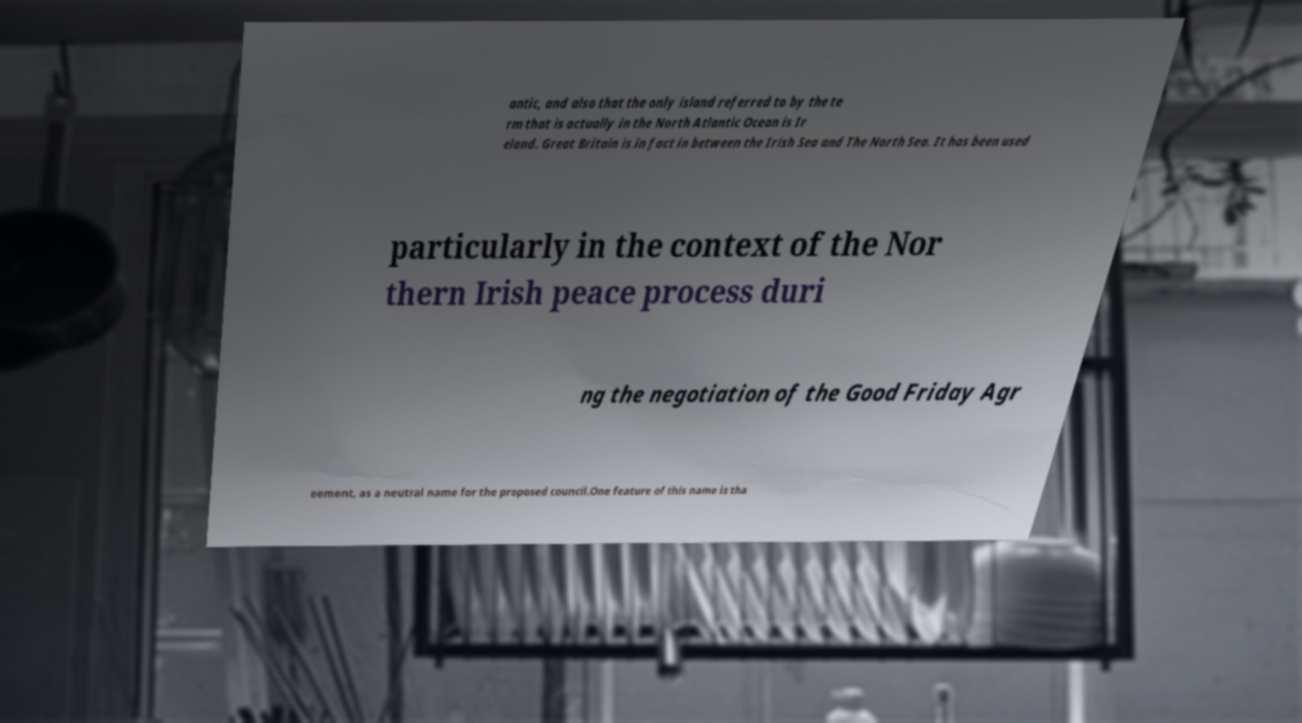Could you assist in decoding the text presented in this image and type it out clearly? antic, and also that the only island referred to by the te rm that is actually in the North Atlantic Ocean is Ir eland. Great Britain is in fact in between the Irish Sea and The North Sea. It has been used particularly in the context of the Nor thern Irish peace process duri ng the negotiation of the Good Friday Agr eement, as a neutral name for the proposed council.One feature of this name is tha 